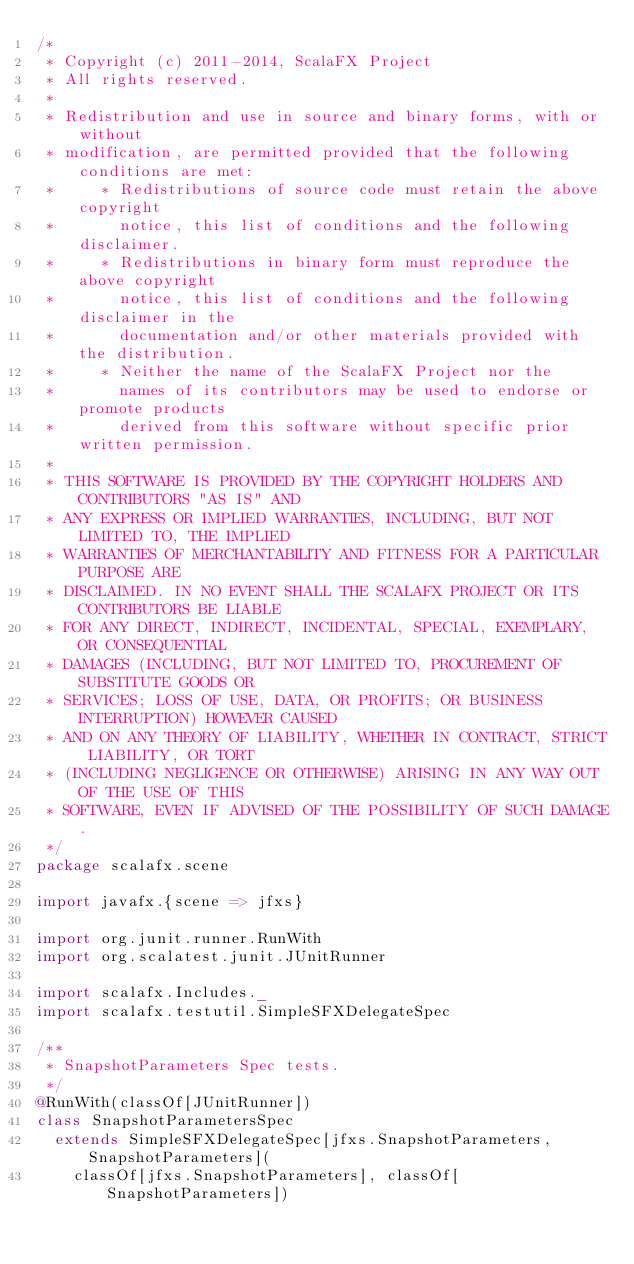<code> <loc_0><loc_0><loc_500><loc_500><_Scala_>/*
 * Copyright (c) 2011-2014, ScalaFX Project
 * All rights reserved.
 *
 * Redistribution and use in source and binary forms, with or without
 * modification, are permitted provided that the following conditions are met:
 *     * Redistributions of source code must retain the above copyright
 *       notice, this list of conditions and the following disclaimer.
 *     * Redistributions in binary form must reproduce the above copyright
 *       notice, this list of conditions and the following disclaimer in the
 *       documentation and/or other materials provided with the distribution.
 *     * Neither the name of the ScalaFX Project nor the
 *       names of its contributors may be used to endorse or promote products
 *       derived from this software without specific prior written permission.
 *
 * THIS SOFTWARE IS PROVIDED BY THE COPYRIGHT HOLDERS AND CONTRIBUTORS "AS IS" AND
 * ANY EXPRESS OR IMPLIED WARRANTIES, INCLUDING, BUT NOT LIMITED TO, THE IMPLIED
 * WARRANTIES OF MERCHANTABILITY AND FITNESS FOR A PARTICULAR PURPOSE ARE
 * DISCLAIMED. IN NO EVENT SHALL THE SCALAFX PROJECT OR ITS CONTRIBUTORS BE LIABLE
 * FOR ANY DIRECT, INDIRECT, INCIDENTAL, SPECIAL, EXEMPLARY, OR CONSEQUENTIAL
 * DAMAGES (INCLUDING, BUT NOT LIMITED TO, PROCUREMENT OF SUBSTITUTE GOODS OR
 * SERVICES; LOSS OF USE, DATA, OR PROFITS; OR BUSINESS INTERRUPTION) HOWEVER CAUSED
 * AND ON ANY THEORY OF LIABILITY, WHETHER IN CONTRACT, STRICT LIABILITY, OR TORT
 * (INCLUDING NEGLIGENCE OR OTHERWISE) ARISING IN ANY WAY OUT OF THE USE OF THIS
 * SOFTWARE, EVEN IF ADVISED OF THE POSSIBILITY OF SUCH DAMAGE.
 */
package scalafx.scene

import javafx.{scene => jfxs}

import org.junit.runner.RunWith
import org.scalatest.junit.JUnitRunner

import scalafx.Includes._
import scalafx.testutil.SimpleSFXDelegateSpec

/**
 * SnapshotParameters Spec tests.
 */
@RunWith(classOf[JUnitRunner])
class SnapshotParametersSpec
  extends SimpleSFXDelegateSpec[jfxs.SnapshotParameters, SnapshotParameters](
    classOf[jfxs.SnapshotParameters], classOf[SnapshotParameters])
</code> 